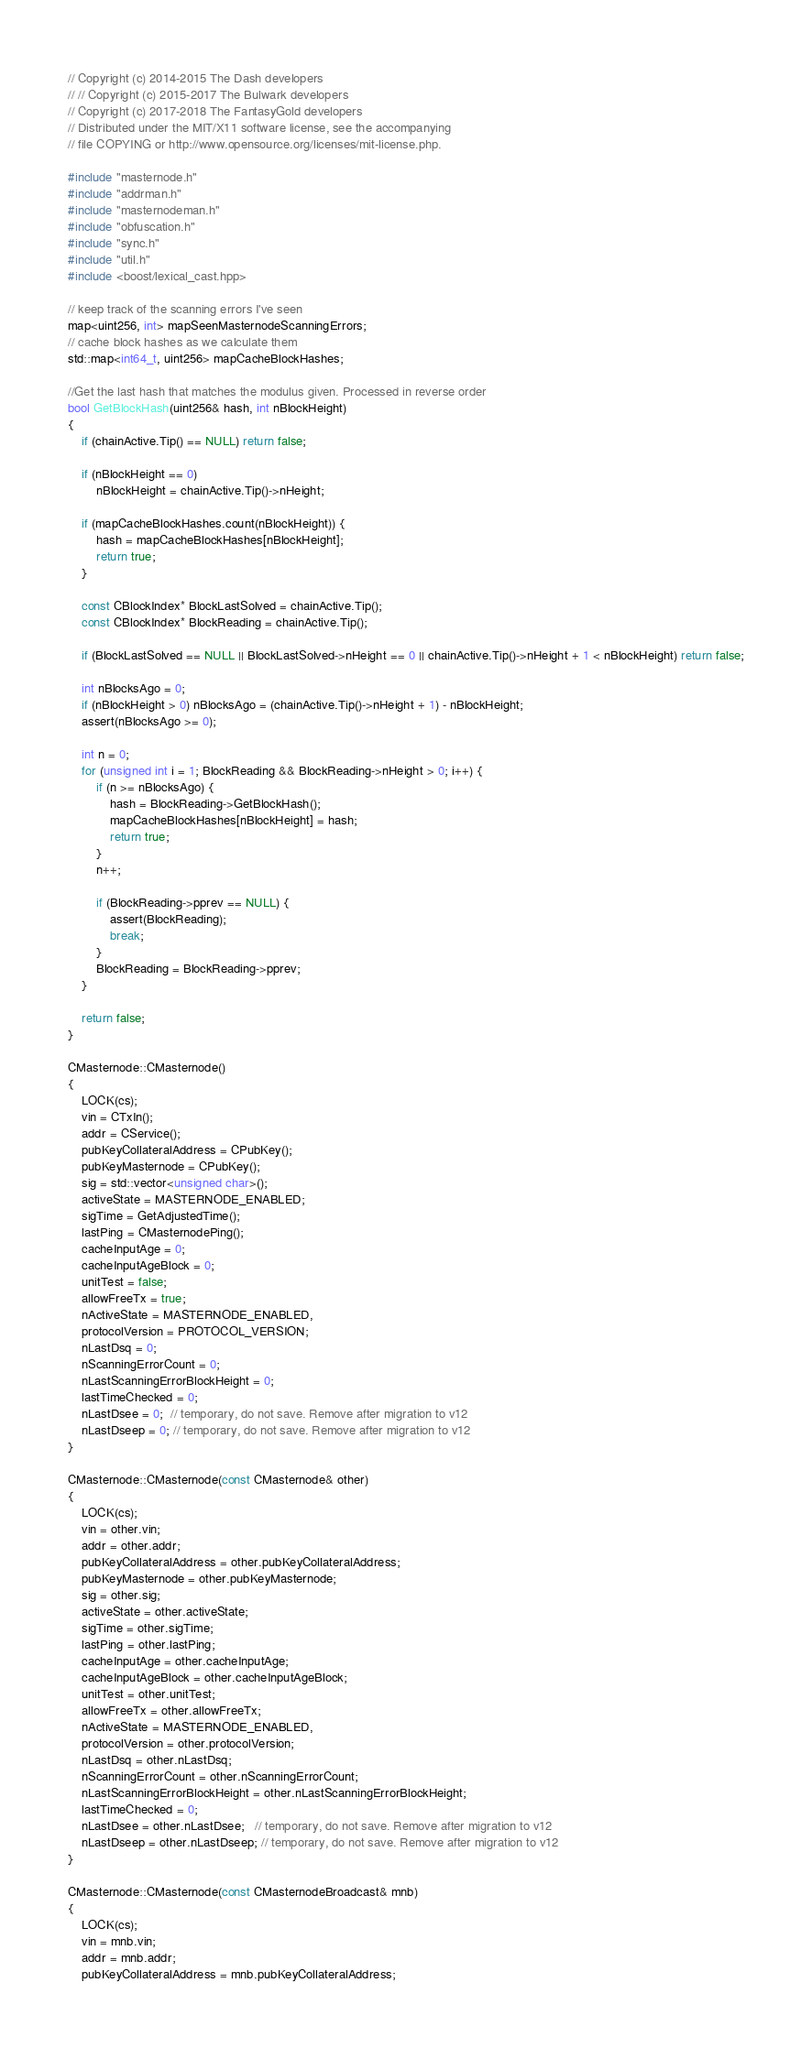<code> <loc_0><loc_0><loc_500><loc_500><_C++_>// Copyright (c) 2014-2015 The Dash developers
// // Copyright (c) 2015-2017 The Bulwark developers
// Copyright (c) 2017-2018 The FantasyGold developers
// Distributed under the MIT/X11 software license, see the accompanying
// file COPYING or http://www.opensource.org/licenses/mit-license.php.

#include "masternode.h"
#include "addrman.h"
#include "masternodeman.h"
#include "obfuscation.h"
#include "sync.h"
#include "util.h"
#include <boost/lexical_cast.hpp>

// keep track of the scanning errors I've seen
map<uint256, int> mapSeenMasternodeScanningErrors;
// cache block hashes as we calculate them
std::map<int64_t, uint256> mapCacheBlockHashes;

//Get the last hash that matches the modulus given. Processed in reverse order
bool GetBlockHash(uint256& hash, int nBlockHeight)
{
    if (chainActive.Tip() == NULL) return false;

    if (nBlockHeight == 0)
        nBlockHeight = chainActive.Tip()->nHeight;

    if (mapCacheBlockHashes.count(nBlockHeight)) {
        hash = mapCacheBlockHashes[nBlockHeight];
        return true;
    }

    const CBlockIndex* BlockLastSolved = chainActive.Tip();
    const CBlockIndex* BlockReading = chainActive.Tip();

    if (BlockLastSolved == NULL || BlockLastSolved->nHeight == 0 || chainActive.Tip()->nHeight + 1 < nBlockHeight) return false;

    int nBlocksAgo = 0;
    if (nBlockHeight > 0) nBlocksAgo = (chainActive.Tip()->nHeight + 1) - nBlockHeight;
    assert(nBlocksAgo >= 0);

    int n = 0;
    for (unsigned int i = 1; BlockReading && BlockReading->nHeight > 0; i++) {
        if (n >= nBlocksAgo) {
            hash = BlockReading->GetBlockHash();
            mapCacheBlockHashes[nBlockHeight] = hash;
            return true;
        }
        n++;

        if (BlockReading->pprev == NULL) {
            assert(BlockReading);
            break;
        }
        BlockReading = BlockReading->pprev;
    }

    return false;
}

CMasternode::CMasternode()
{
    LOCK(cs);
    vin = CTxIn();
    addr = CService();
    pubKeyCollateralAddress = CPubKey();
    pubKeyMasternode = CPubKey();
    sig = std::vector<unsigned char>();
    activeState = MASTERNODE_ENABLED;
    sigTime = GetAdjustedTime();
    lastPing = CMasternodePing();
    cacheInputAge = 0;
    cacheInputAgeBlock = 0;
    unitTest = false;
    allowFreeTx = true;
    nActiveState = MASTERNODE_ENABLED,
    protocolVersion = PROTOCOL_VERSION;
    nLastDsq = 0;
    nScanningErrorCount = 0;
    nLastScanningErrorBlockHeight = 0;
    lastTimeChecked = 0;
    nLastDsee = 0;  // temporary, do not save. Remove after migration to v12
    nLastDseep = 0; // temporary, do not save. Remove after migration to v12
}

CMasternode::CMasternode(const CMasternode& other)
{
    LOCK(cs);
    vin = other.vin;
    addr = other.addr;
    pubKeyCollateralAddress = other.pubKeyCollateralAddress;
    pubKeyMasternode = other.pubKeyMasternode;
    sig = other.sig;
    activeState = other.activeState;
    sigTime = other.sigTime;
    lastPing = other.lastPing;
    cacheInputAge = other.cacheInputAge;
    cacheInputAgeBlock = other.cacheInputAgeBlock;
    unitTest = other.unitTest;
    allowFreeTx = other.allowFreeTx;
    nActiveState = MASTERNODE_ENABLED,
    protocolVersion = other.protocolVersion;
    nLastDsq = other.nLastDsq;
    nScanningErrorCount = other.nScanningErrorCount;
    nLastScanningErrorBlockHeight = other.nLastScanningErrorBlockHeight;
    lastTimeChecked = 0;
    nLastDsee = other.nLastDsee;   // temporary, do not save. Remove after migration to v12
    nLastDseep = other.nLastDseep; // temporary, do not save. Remove after migration to v12
}

CMasternode::CMasternode(const CMasternodeBroadcast& mnb)
{
    LOCK(cs);
    vin = mnb.vin;
    addr = mnb.addr;
    pubKeyCollateralAddress = mnb.pubKeyCollateralAddress;</code> 